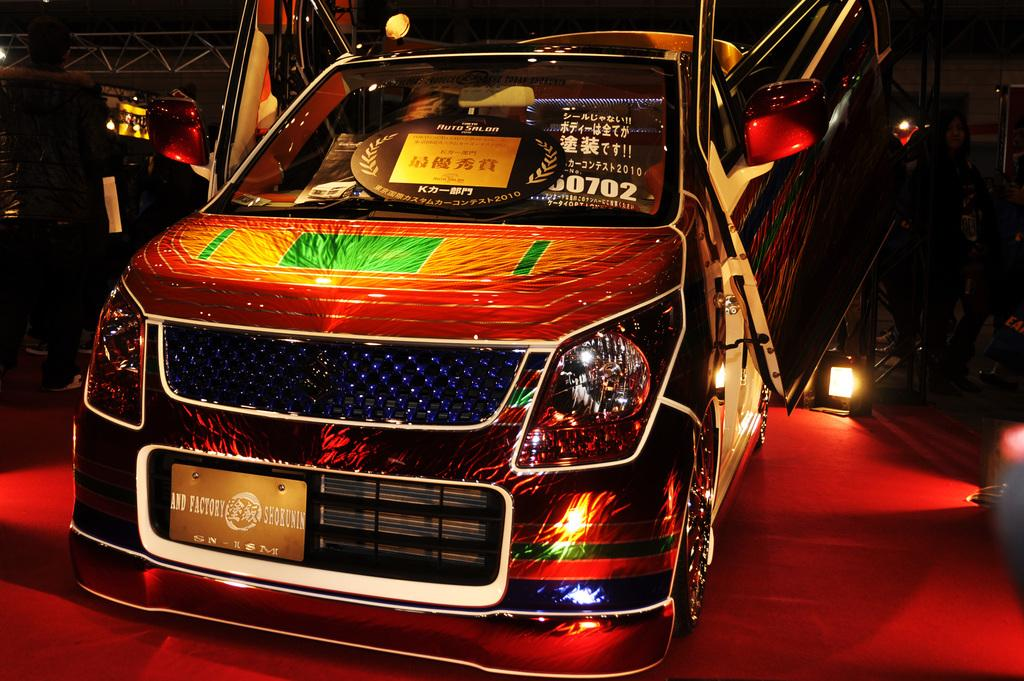What is the main subject of the image? There is a vehicle in the image. What is located at the bottom of the image? There is a carpet at the bottom of the image. What can be seen in the background of the image? There are lights visible in the background of the image. What objects are present in the image that are not the vehicle or carpet? There are rods in the image. What type of skin condition can be seen on the vehicle in the image? There is no skin condition present on the vehicle in the image, as vehicles do not have skin. 